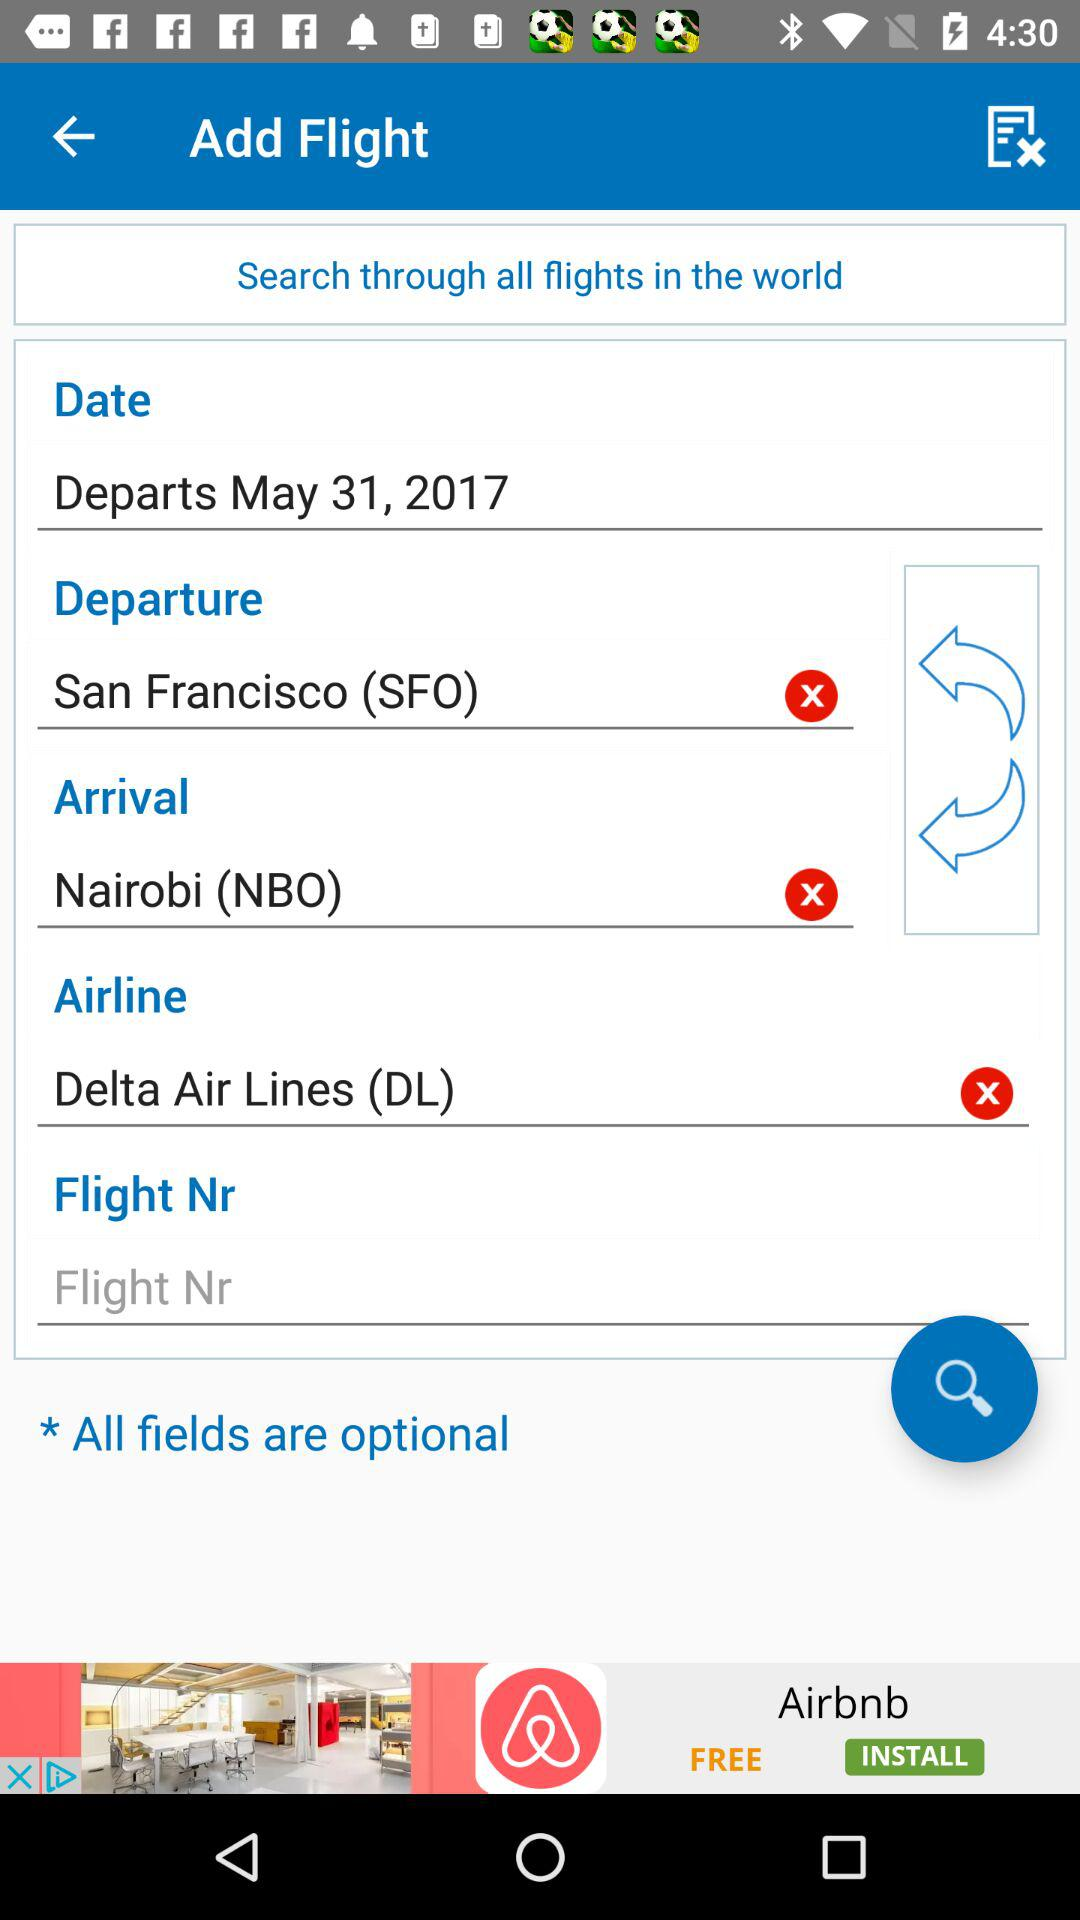Where will the flight arrive? The flight will arrive in Nairobi (NBO). 